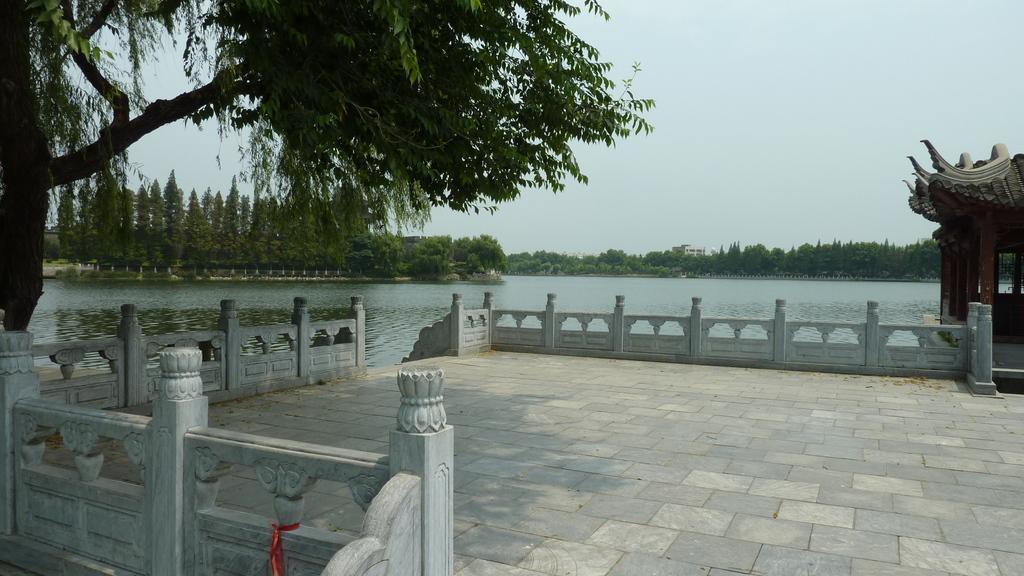How would you summarize this image in a sentence or two? Here in this picture, in the front we can see a place that is covered with wall type railing and on the right side we can see a shed present and we can see water covered over the place and we can see plants and trees present on the ground and we can see the sky is cloudy. 